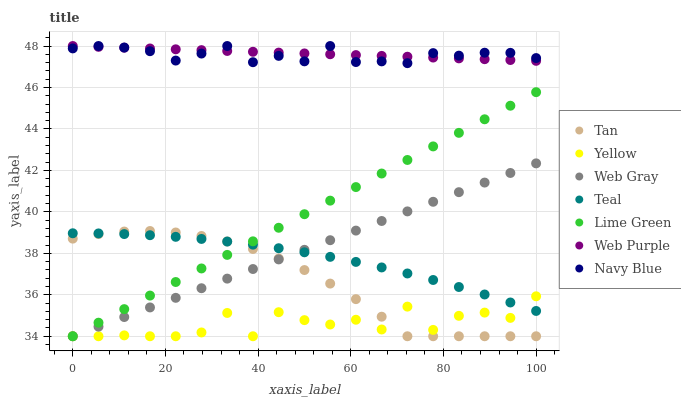Does Yellow have the minimum area under the curve?
Answer yes or no. Yes. Does Web Purple have the maximum area under the curve?
Answer yes or no. Yes. Does Navy Blue have the minimum area under the curve?
Answer yes or no. No. Does Navy Blue have the maximum area under the curve?
Answer yes or no. No. Is Web Purple the smoothest?
Answer yes or no. Yes. Is Yellow the roughest?
Answer yes or no. Yes. Is Navy Blue the smoothest?
Answer yes or no. No. Is Navy Blue the roughest?
Answer yes or no. No. Does Web Gray have the lowest value?
Answer yes or no. Yes. Does Navy Blue have the lowest value?
Answer yes or no. No. Does Web Purple have the highest value?
Answer yes or no. Yes. Does Yellow have the highest value?
Answer yes or no. No. Is Yellow less than Web Purple?
Answer yes or no. Yes. Is Web Purple greater than Tan?
Answer yes or no. Yes. Does Navy Blue intersect Web Purple?
Answer yes or no. Yes. Is Navy Blue less than Web Purple?
Answer yes or no. No. Is Navy Blue greater than Web Purple?
Answer yes or no. No. Does Yellow intersect Web Purple?
Answer yes or no. No. 